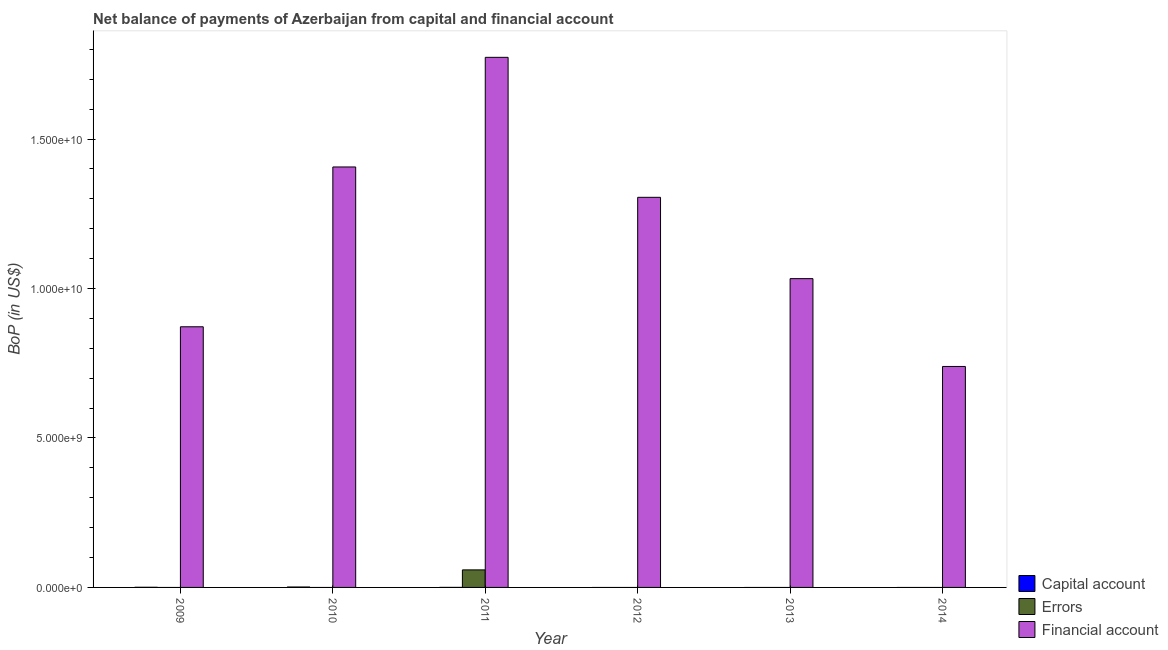Are the number of bars per tick equal to the number of legend labels?
Keep it short and to the point. No. Are the number of bars on each tick of the X-axis equal?
Give a very brief answer. No. How many bars are there on the 4th tick from the left?
Your answer should be very brief. 1. How many bars are there on the 1st tick from the right?
Offer a terse response. 1. What is the label of the 2nd group of bars from the left?
Ensure brevity in your answer.  2010. In how many cases, is the number of bars for a given year not equal to the number of legend labels?
Your response must be concise. 5. What is the amount of net capital account in 2012?
Provide a succinct answer. 0. Across all years, what is the maximum amount of net capital account?
Provide a succinct answer. 1.43e+07. What is the total amount of net capital account in the graph?
Your answer should be very brief. 2.06e+07. What is the difference between the amount of financial account in 2010 and that in 2013?
Your answer should be compact. 3.74e+09. What is the difference between the amount of errors in 2011 and the amount of net capital account in 2009?
Give a very brief answer. 5.87e+08. What is the average amount of financial account per year?
Give a very brief answer. 1.19e+1. In the year 2009, what is the difference between the amount of net capital account and amount of financial account?
Your response must be concise. 0. In how many years, is the amount of financial account greater than 2000000000 US$?
Offer a very short reply. 6. What is the ratio of the amount of financial account in 2009 to that in 2011?
Your response must be concise. 0.49. Is the amount of financial account in 2009 less than that in 2014?
Your answer should be compact. No. What is the difference between the highest and the second highest amount of financial account?
Your answer should be very brief. 3.67e+09. What is the difference between the highest and the lowest amount of financial account?
Your response must be concise. 1.03e+1. Is the sum of the amount of financial account in 2012 and 2014 greater than the maximum amount of errors across all years?
Give a very brief answer. Yes. Is it the case that in every year, the sum of the amount of net capital account and amount of errors is greater than the amount of financial account?
Offer a terse response. No. Are all the bars in the graph horizontal?
Keep it short and to the point. No. How many years are there in the graph?
Your response must be concise. 6. Are the values on the major ticks of Y-axis written in scientific E-notation?
Give a very brief answer. Yes. Does the graph contain any zero values?
Your response must be concise. Yes. How are the legend labels stacked?
Make the answer very short. Vertical. What is the title of the graph?
Give a very brief answer. Net balance of payments of Azerbaijan from capital and financial account. Does "New Zealand" appear as one of the legend labels in the graph?
Keep it short and to the point. No. What is the label or title of the X-axis?
Your answer should be compact. Year. What is the label or title of the Y-axis?
Keep it short and to the point. BoP (in US$). What is the BoP (in US$) in Capital account in 2009?
Provide a short and direct response. 5.35e+06. What is the BoP (in US$) in Financial account in 2009?
Offer a terse response. 8.72e+09. What is the BoP (in US$) in Capital account in 2010?
Give a very brief answer. 1.43e+07. What is the BoP (in US$) in Errors in 2010?
Offer a very short reply. 0. What is the BoP (in US$) in Financial account in 2010?
Offer a very short reply. 1.41e+1. What is the BoP (in US$) of Capital account in 2011?
Your answer should be compact. 9.11e+05. What is the BoP (in US$) in Errors in 2011?
Offer a very short reply. 5.87e+08. What is the BoP (in US$) of Financial account in 2011?
Ensure brevity in your answer.  1.77e+1. What is the BoP (in US$) of Capital account in 2012?
Provide a short and direct response. 0. What is the BoP (in US$) in Financial account in 2012?
Offer a very short reply. 1.30e+1. What is the BoP (in US$) of Capital account in 2013?
Provide a short and direct response. 0. What is the BoP (in US$) of Errors in 2013?
Your answer should be compact. 0. What is the BoP (in US$) of Financial account in 2013?
Ensure brevity in your answer.  1.03e+1. What is the BoP (in US$) in Capital account in 2014?
Your response must be concise. 0. What is the BoP (in US$) in Errors in 2014?
Make the answer very short. 0. What is the BoP (in US$) of Financial account in 2014?
Provide a short and direct response. 7.39e+09. Across all years, what is the maximum BoP (in US$) of Capital account?
Ensure brevity in your answer.  1.43e+07. Across all years, what is the maximum BoP (in US$) in Errors?
Provide a succinct answer. 5.87e+08. Across all years, what is the maximum BoP (in US$) of Financial account?
Provide a short and direct response. 1.77e+1. Across all years, what is the minimum BoP (in US$) of Financial account?
Offer a very short reply. 7.39e+09. What is the total BoP (in US$) in Capital account in the graph?
Provide a short and direct response. 2.06e+07. What is the total BoP (in US$) of Errors in the graph?
Offer a terse response. 5.87e+08. What is the total BoP (in US$) of Financial account in the graph?
Provide a succinct answer. 7.13e+1. What is the difference between the BoP (in US$) in Capital account in 2009 and that in 2010?
Your response must be concise. -8.94e+06. What is the difference between the BoP (in US$) in Financial account in 2009 and that in 2010?
Your answer should be compact. -5.35e+09. What is the difference between the BoP (in US$) in Capital account in 2009 and that in 2011?
Provide a short and direct response. 4.44e+06. What is the difference between the BoP (in US$) of Financial account in 2009 and that in 2011?
Your response must be concise. -9.01e+09. What is the difference between the BoP (in US$) of Financial account in 2009 and that in 2012?
Your answer should be compact. -4.33e+09. What is the difference between the BoP (in US$) in Financial account in 2009 and that in 2013?
Ensure brevity in your answer.  -1.61e+09. What is the difference between the BoP (in US$) in Financial account in 2009 and that in 2014?
Offer a very short reply. 1.33e+09. What is the difference between the BoP (in US$) of Capital account in 2010 and that in 2011?
Provide a succinct answer. 1.34e+07. What is the difference between the BoP (in US$) in Financial account in 2010 and that in 2011?
Offer a terse response. -3.67e+09. What is the difference between the BoP (in US$) in Financial account in 2010 and that in 2012?
Ensure brevity in your answer.  1.02e+09. What is the difference between the BoP (in US$) of Financial account in 2010 and that in 2013?
Make the answer very short. 3.74e+09. What is the difference between the BoP (in US$) of Financial account in 2010 and that in 2014?
Your answer should be very brief. 6.67e+09. What is the difference between the BoP (in US$) in Financial account in 2011 and that in 2012?
Give a very brief answer. 4.68e+09. What is the difference between the BoP (in US$) of Financial account in 2011 and that in 2013?
Your answer should be very brief. 7.40e+09. What is the difference between the BoP (in US$) of Financial account in 2011 and that in 2014?
Make the answer very short. 1.03e+1. What is the difference between the BoP (in US$) in Financial account in 2012 and that in 2013?
Your answer should be compact. 2.72e+09. What is the difference between the BoP (in US$) of Financial account in 2012 and that in 2014?
Your answer should be compact. 5.66e+09. What is the difference between the BoP (in US$) in Financial account in 2013 and that in 2014?
Provide a short and direct response. 2.94e+09. What is the difference between the BoP (in US$) in Capital account in 2009 and the BoP (in US$) in Financial account in 2010?
Provide a short and direct response. -1.41e+1. What is the difference between the BoP (in US$) in Capital account in 2009 and the BoP (in US$) in Errors in 2011?
Provide a short and direct response. -5.81e+08. What is the difference between the BoP (in US$) of Capital account in 2009 and the BoP (in US$) of Financial account in 2011?
Your answer should be compact. -1.77e+1. What is the difference between the BoP (in US$) of Capital account in 2009 and the BoP (in US$) of Financial account in 2012?
Your answer should be very brief. -1.30e+1. What is the difference between the BoP (in US$) of Capital account in 2009 and the BoP (in US$) of Financial account in 2013?
Keep it short and to the point. -1.03e+1. What is the difference between the BoP (in US$) in Capital account in 2009 and the BoP (in US$) in Financial account in 2014?
Offer a very short reply. -7.39e+09. What is the difference between the BoP (in US$) in Capital account in 2010 and the BoP (in US$) in Errors in 2011?
Provide a succinct answer. -5.72e+08. What is the difference between the BoP (in US$) of Capital account in 2010 and the BoP (in US$) of Financial account in 2011?
Offer a very short reply. -1.77e+1. What is the difference between the BoP (in US$) of Capital account in 2010 and the BoP (in US$) of Financial account in 2012?
Give a very brief answer. -1.30e+1. What is the difference between the BoP (in US$) of Capital account in 2010 and the BoP (in US$) of Financial account in 2013?
Your answer should be very brief. -1.03e+1. What is the difference between the BoP (in US$) of Capital account in 2010 and the BoP (in US$) of Financial account in 2014?
Provide a succinct answer. -7.38e+09. What is the difference between the BoP (in US$) of Capital account in 2011 and the BoP (in US$) of Financial account in 2012?
Ensure brevity in your answer.  -1.30e+1. What is the difference between the BoP (in US$) in Errors in 2011 and the BoP (in US$) in Financial account in 2012?
Provide a short and direct response. -1.25e+1. What is the difference between the BoP (in US$) of Capital account in 2011 and the BoP (in US$) of Financial account in 2013?
Your response must be concise. -1.03e+1. What is the difference between the BoP (in US$) of Errors in 2011 and the BoP (in US$) of Financial account in 2013?
Your response must be concise. -9.74e+09. What is the difference between the BoP (in US$) of Capital account in 2011 and the BoP (in US$) of Financial account in 2014?
Keep it short and to the point. -7.39e+09. What is the difference between the BoP (in US$) in Errors in 2011 and the BoP (in US$) in Financial account in 2014?
Make the answer very short. -6.80e+09. What is the average BoP (in US$) of Capital account per year?
Provide a short and direct response. 3.43e+06. What is the average BoP (in US$) of Errors per year?
Provide a succinct answer. 9.78e+07. What is the average BoP (in US$) in Financial account per year?
Your answer should be very brief. 1.19e+1. In the year 2009, what is the difference between the BoP (in US$) of Capital account and BoP (in US$) of Financial account?
Your response must be concise. -8.71e+09. In the year 2010, what is the difference between the BoP (in US$) of Capital account and BoP (in US$) of Financial account?
Provide a short and direct response. -1.41e+1. In the year 2011, what is the difference between the BoP (in US$) of Capital account and BoP (in US$) of Errors?
Offer a very short reply. -5.86e+08. In the year 2011, what is the difference between the BoP (in US$) in Capital account and BoP (in US$) in Financial account?
Ensure brevity in your answer.  -1.77e+1. In the year 2011, what is the difference between the BoP (in US$) of Errors and BoP (in US$) of Financial account?
Give a very brief answer. -1.71e+1. What is the ratio of the BoP (in US$) in Capital account in 2009 to that in 2010?
Give a very brief answer. 0.37. What is the ratio of the BoP (in US$) in Financial account in 2009 to that in 2010?
Offer a terse response. 0.62. What is the ratio of the BoP (in US$) in Capital account in 2009 to that in 2011?
Provide a short and direct response. 5.87. What is the ratio of the BoP (in US$) of Financial account in 2009 to that in 2011?
Your answer should be very brief. 0.49. What is the ratio of the BoP (in US$) in Financial account in 2009 to that in 2012?
Keep it short and to the point. 0.67. What is the ratio of the BoP (in US$) of Financial account in 2009 to that in 2013?
Provide a short and direct response. 0.84. What is the ratio of the BoP (in US$) in Financial account in 2009 to that in 2014?
Your answer should be very brief. 1.18. What is the ratio of the BoP (in US$) of Capital account in 2010 to that in 2011?
Keep it short and to the point. 15.69. What is the ratio of the BoP (in US$) of Financial account in 2010 to that in 2011?
Provide a short and direct response. 0.79. What is the ratio of the BoP (in US$) in Financial account in 2010 to that in 2012?
Make the answer very short. 1.08. What is the ratio of the BoP (in US$) in Financial account in 2010 to that in 2013?
Keep it short and to the point. 1.36. What is the ratio of the BoP (in US$) in Financial account in 2010 to that in 2014?
Your answer should be very brief. 1.9. What is the ratio of the BoP (in US$) in Financial account in 2011 to that in 2012?
Offer a terse response. 1.36. What is the ratio of the BoP (in US$) of Financial account in 2011 to that in 2013?
Your response must be concise. 1.72. What is the ratio of the BoP (in US$) in Financial account in 2011 to that in 2014?
Your response must be concise. 2.4. What is the ratio of the BoP (in US$) of Financial account in 2012 to that in 2013?
Give a very brief answer. 1.26. What is the ratio of the BoP (in US$) of Financial account in 2012 to that in 2014?
Make the answer very short. 1.77. What is the ratio of the BoP (in US$) in Financial account in 2013 to that in 2014?
Provide a short and direct response. 1.4. What is the difference between the highest and the second highest BoP (in US$) in Capital account?
Make the answer very short. 8.94e+06. What is the difference between the highest and the second highest BoP (in US$) in Financial account?
Give a very brief answer. 3.67e+09. What is the difference between the highest and the lowest BoP (in US$) of Capital account?
Provide a short and direct response. 1.43e+07. What is the difference between the highest and the lowest BoP (in US$) of Errors?
Provide a succinct answer. 5.87e+08. What is the difference between the highest and the lowest BoP (in US$) in Financial account?
Keep it short and to the point. 1.03e+1. 